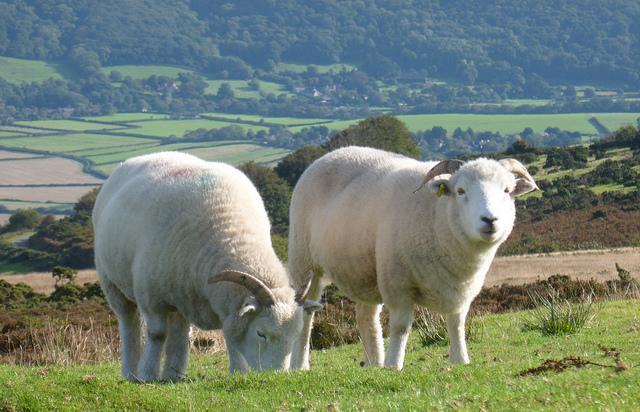How many horns are in this picture?
Give a very brief answer. 4. How many have white faces?
Give a very brief answer. 2. How many sheep are there?
Give a very brief answer. 2. How many giraffes are not drinking?
Give a very brief answer. 0. 